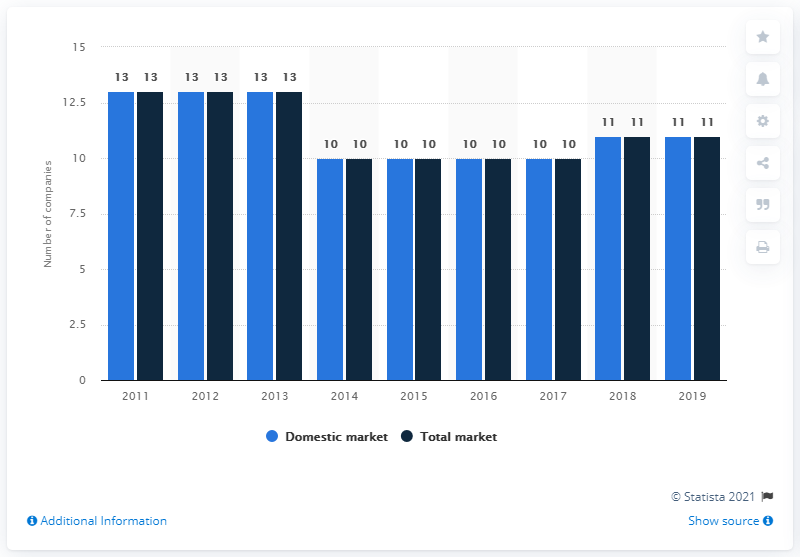List a handful of essential elements in this visual. In 2018, there were 11 insurance companies operating in the Icelandic insurance market. In 2011, there were 13 companies operating in the domestic market. During the period of 2014 to 2017, there were 10 insurance companies operating on the Icelandic insurance market. The difference between the maximum number of companies operating in the domestic market and the minimum number of total companies operating over the years is 3. 